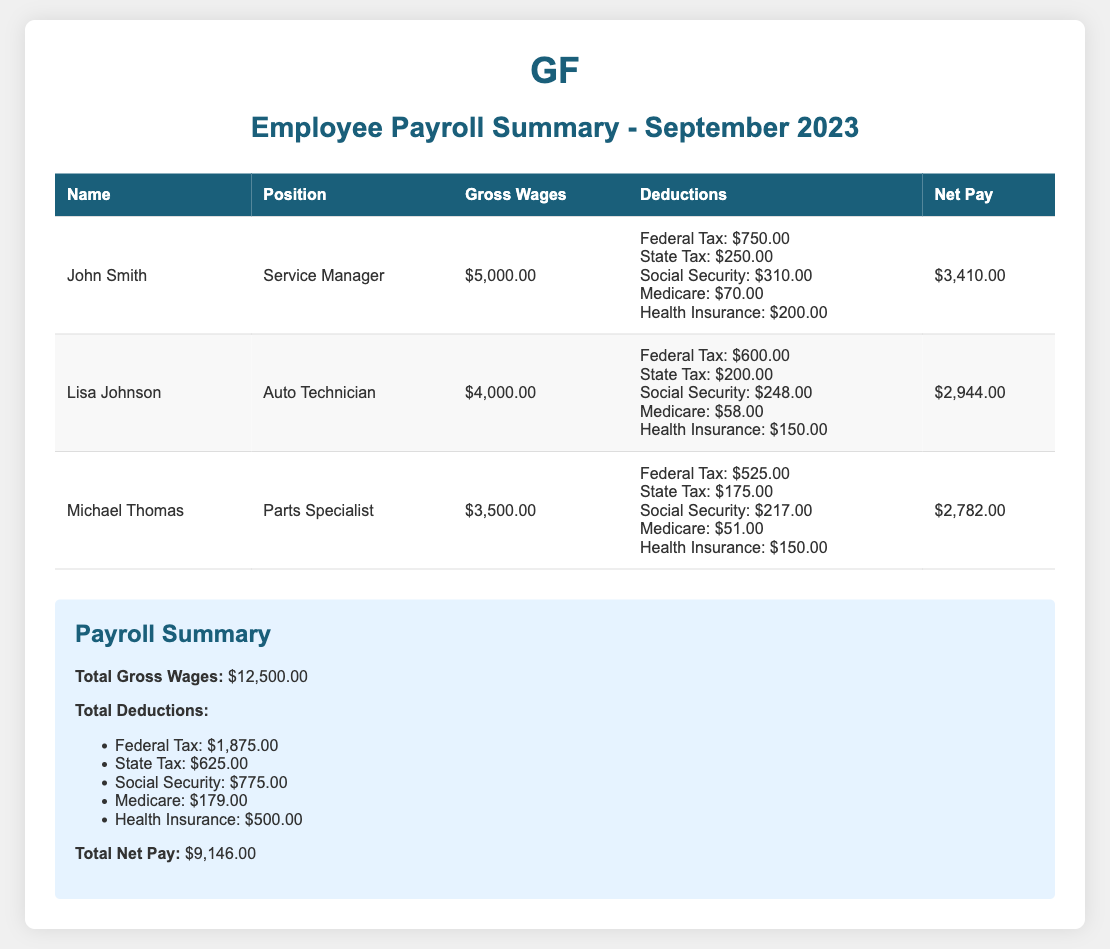What is the total gross wages for September 2023? The total gross wages is the sum of all individual gross wages listed in the document, which is $5,000.00 + $4,000.00 + $3,500.00 = $12,500.00.
Answer: $12,500.00 How much is Lisa Johnson's net pay? Lisa Johnson's net pay is the amount listed in her individual entry, which is $2,944.00.
Answer: $2,944.00 What deductions does Michael Thomas have? The deductions for Michael Thomas include Federal Tax, State Tax, Social Security, Medicare, and Health Insurance, totaling $1,175.00.
Answer: $1,175.00 Who is the Service Manager? The individual serving as Service Manager is specified under the corresponding position title, which is John Smith.
Answer: John Smith What is the total amount deducted for Federal Tax? The total deducted for Federal Tax includes the amounts for all employees: $750.00 (John) + $600.00 (Lisa) + $525.00 (Michael) = $1,875.00.
Answer: $1,875.00 What percentage of John's gross wages is his net pay? To find the percentage, divide John's net pay by his gross wages and multiply by 100: ($3,410.00 / $5,000.00) * 100 = 68.2%.
Answer: 68.2% What is the position of the employee with the highest gross wages? The employee with the highest gross wages is the Service Manager, as indicated by John Smith's position in the document.
Answer: Service Manager What is the total net pay for all employees? The total net pay for all employees is the sum of each individual employee's net pay: $3,410.00 + $2,944.00 + $2,782.00 = $9,146.00.
Answer: $9,146.00 How much does the company pay for Health Insurance in total? The total amount deducted for Health Insurance across all employees is $200.00 (John) + $150.00 (Lisa) + $150.00 (Michael) = $500.00.
Answer: $500.00 